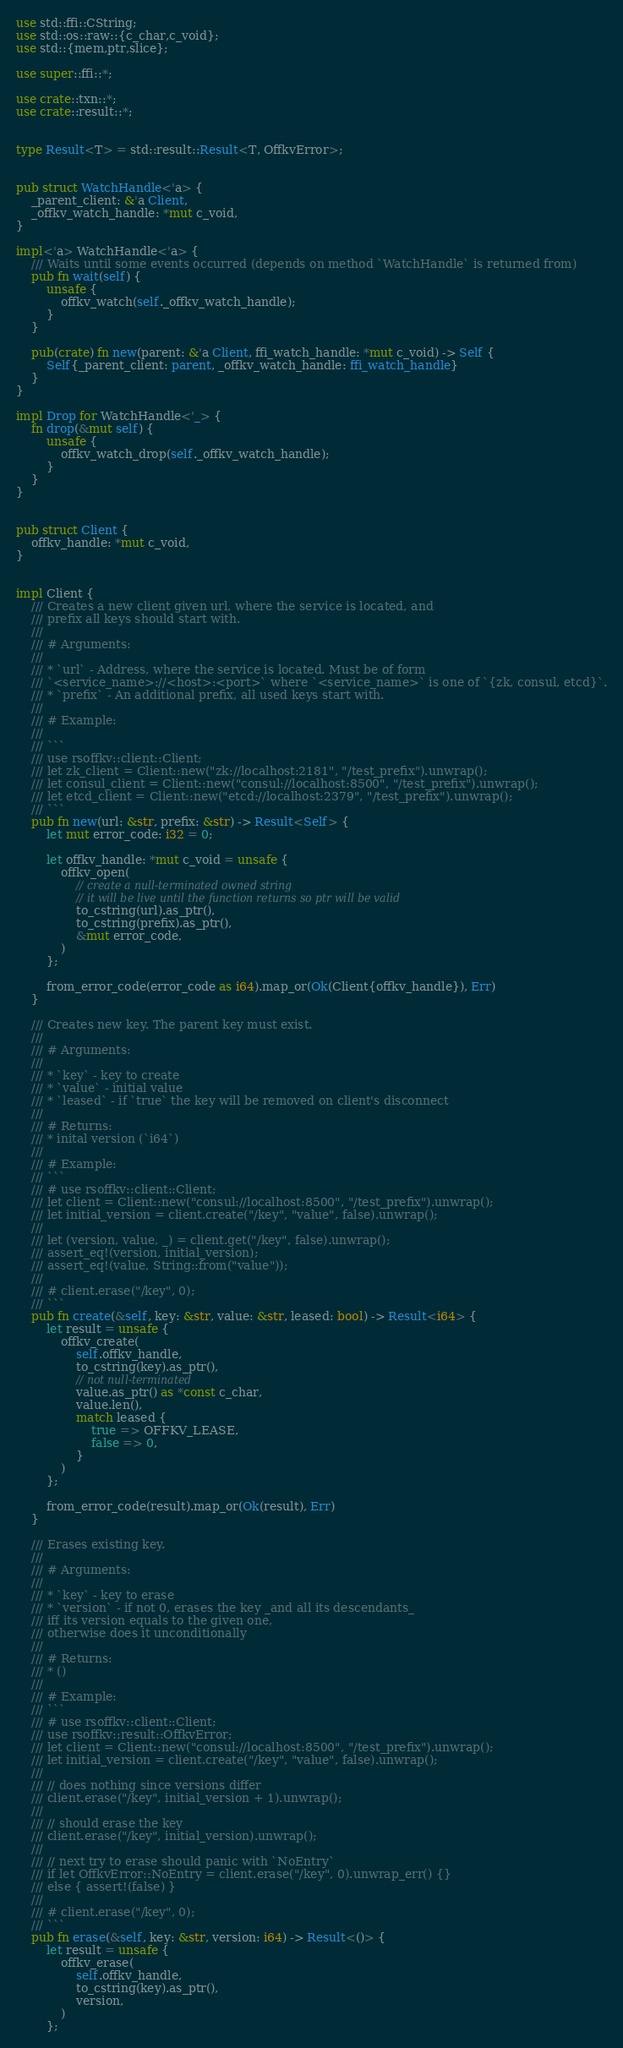Convert code to text. <code><loc_0><loc_0><loc_500><loc_500><_Rust_>use std::ffi::CString;
use std::os::raw::{c_char,c_void};
use std::{mem,ptr,slice};

use super::ffi::*;

use crate::txn::*;
use crate::result::*;


type Result<T> = std::result::Result<T, OffkvError>;


pub struct WatchHandle<'a> {
    _parent_client: &'a Client,
    _offkv_watch_handle: *mut c_void,
}

impl<'a> WatchHandle<'a> {
    /// Waits until some events occurred (depends on method `WatchHandle` is returned from)
    pub fn wait(self) {
        unsafe {
            offkv_watch(self._offkv_watch_handle);
        }
    }

    pub(crate) fn new(parent: &'a Client, ffi_watch_handle: *mut c_void) -> Self {
        Self{_parent_client: parent, _offkv_watch_handle: ffi_watch_handle}
    }
}

impl Drop for WatchHandle<'_> {
    fn drop(&mut self) {
        unsafe {
            offkv_watch_drop(self._offkv_watch_handle);
        }
    }
}


pub struct Client {
    offkv_handle: *mut c_void,
}


impl Client {
    /// Creates a new client given url, where the service is located, and
    /// prefix all keys should start with.
    ///
    /// # Arguments:
    ///
    /// * `url` - Address, where the service is located. Must be of form
    /// `<service_name>://<host>:<port>` where `<service_name>` is one of `{zk, consul, etcd}`.
    /// * `prefix` - An additional prefix, all used keys start with.
    ///
    /// # Example:
    ///
    /// ```
    /// use rsoffkv::client::Client;
    /// let zk_client = Client::new("zk://localhost:2181", "/test_prefix").unwrap();
    /// let consul_client = Client::new("consul://localhost:8500", "/test_prefix").unwrap();
    /// let etcd_client = Client::new("etcd://localhost:2379", "/test_prefix").unwrap();
    /// ```
    pub fn new(url: &str, prefix: &str) -> Result<Self> {
        let mut error_code: i32 = 0;

        let offkv_handle: *mut c_void = unsafe {
            offkv_open(
                // create a null-terminated owned string
                // it will be live until the function returns so ptr will be valid
                to_cstring(url).as_ptr(),
                to_cstring(prefix).as_ptr(),
                &mut error_code,
            )
        };

        from_error_code(error_code as i64).map_or(Ok(Client{offkv_handle}), Err)
    }

    /// Creates new key. The parent key must exist.
    ///
    /// # Arguments:
    ///
    /// * `key` - key to create
    /// * `value` - initial value
    /// * `leased` - if `true` the key will be removed on client's disconnect
    ///
    /// # Returns:
    /// * inital version (`i64`)
    ///
    /// # Example:
    /// ```
    /// # use rsoffkv::client::Client;
    /// let client = Client::new("consul://localhost:8500", "/test_prefix").unwrap();
    /// let initial_version = client.create("/key", "value", false).unwrap();
    ///
    /// let (version, value, _) = client.get("/key", false).unwrap();
    /// assert_eq!(version, initial_version);
    /// assert_eq!(value, String::from("value"));
    ///
    /// # client.erase("/key", 0);
    /// ```
    pub fn create(&self, key: &str, value: &str, leased: bool) -> Result<i64> {
        let result = unsafe {
            offkv_create(
                self.offkv_handle,
                to_cstring(key).as_ptr(),
                // not null-terminated
                value.as_ptr() as *const c_char,
                value.len(),
                match leased {
                    true => OFFKV_LEASE,
                    false => 0,
                }
            )
        };

        from_error_code(result).map_or(Ok(result), Err)
    }

    /// Erases existing key.
    ///
    /// # Arguments:
    ///
    /// * `key` - key to erase
    /// * `version` - if not 0, erases the key _and all its descendants_
    /// iff its version equals to the given one,
    /// otherwise does it unconditionally
    ///
    /// # Returns:
    /// * ()
    ///
    /// # Example:
    /// ```
    /// # use rsoffkv::client::Client;
    /// use rsoffkv::result::OffkvError;
    /// let client = Client::new("consul://localhost:8500", "/test_prefix").unwrap();
    /// let initial_version = client.create("/key", "value", false).unwrap();
    ///
    /// // does nothing since versions differ
    /// client.erase("/key", initial_version + 1).unwrap();
    ///
    /// // should erase the key
    /// client.erase("/key", initial_version).unwrap();
    ///
    /// // next try to erase should panic with `NoEntry`
    /// if let OffkvError::NoEntry = client.erase("/key", 0).unwrap_err() {}
    /// else { assert!(false) }
    ///
    /// # client.erase("/key", 0);
    /// ```
    pub fn erase(&self, key: &str, version: i64) -> Result<()> {
        let result = unsafe {
            offkv_erase(
                self.offkv_handle,
                to_cstring(key).as_ptr(),
                version,
            )
        };
</code> 